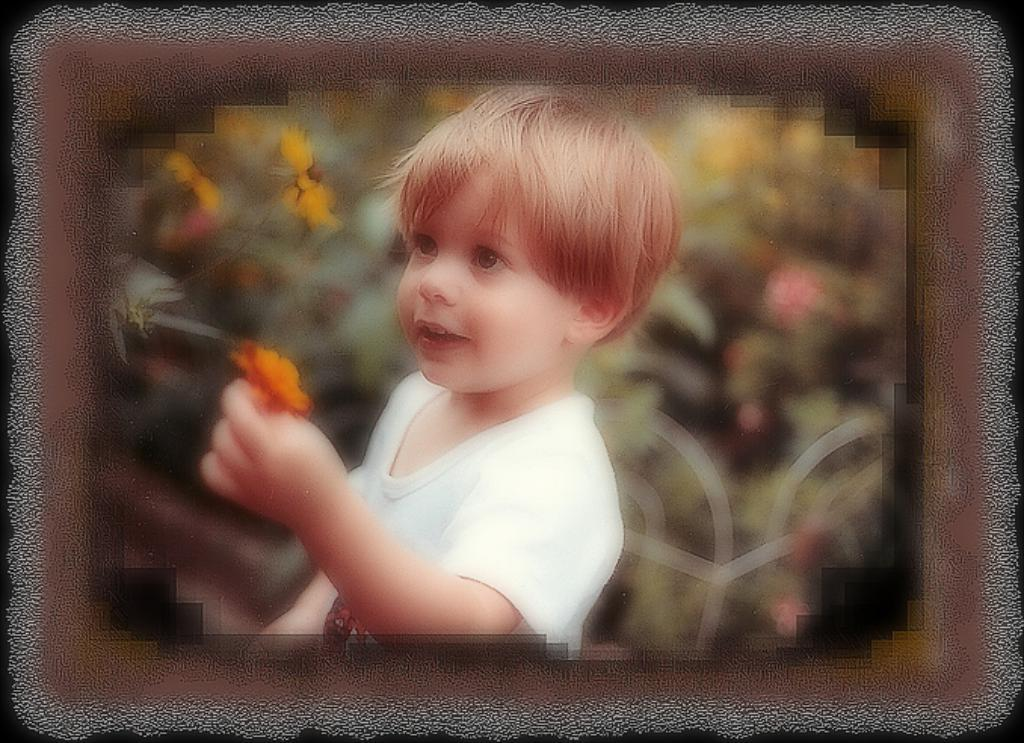Who is the main subject in the image? There is a boy in the center of the image. What is the boy holding in the image? The boy is holding a flower. What expression does the boy have in the image? The boy is smiling. What can be seen in the background of the image? There are plants and flowers in the background of the image. What type of coil is wrapped around the boy's neck in the image? There is no coil present in the image. How many servants are attending to the boy in the image? There are no servants present in the image. 